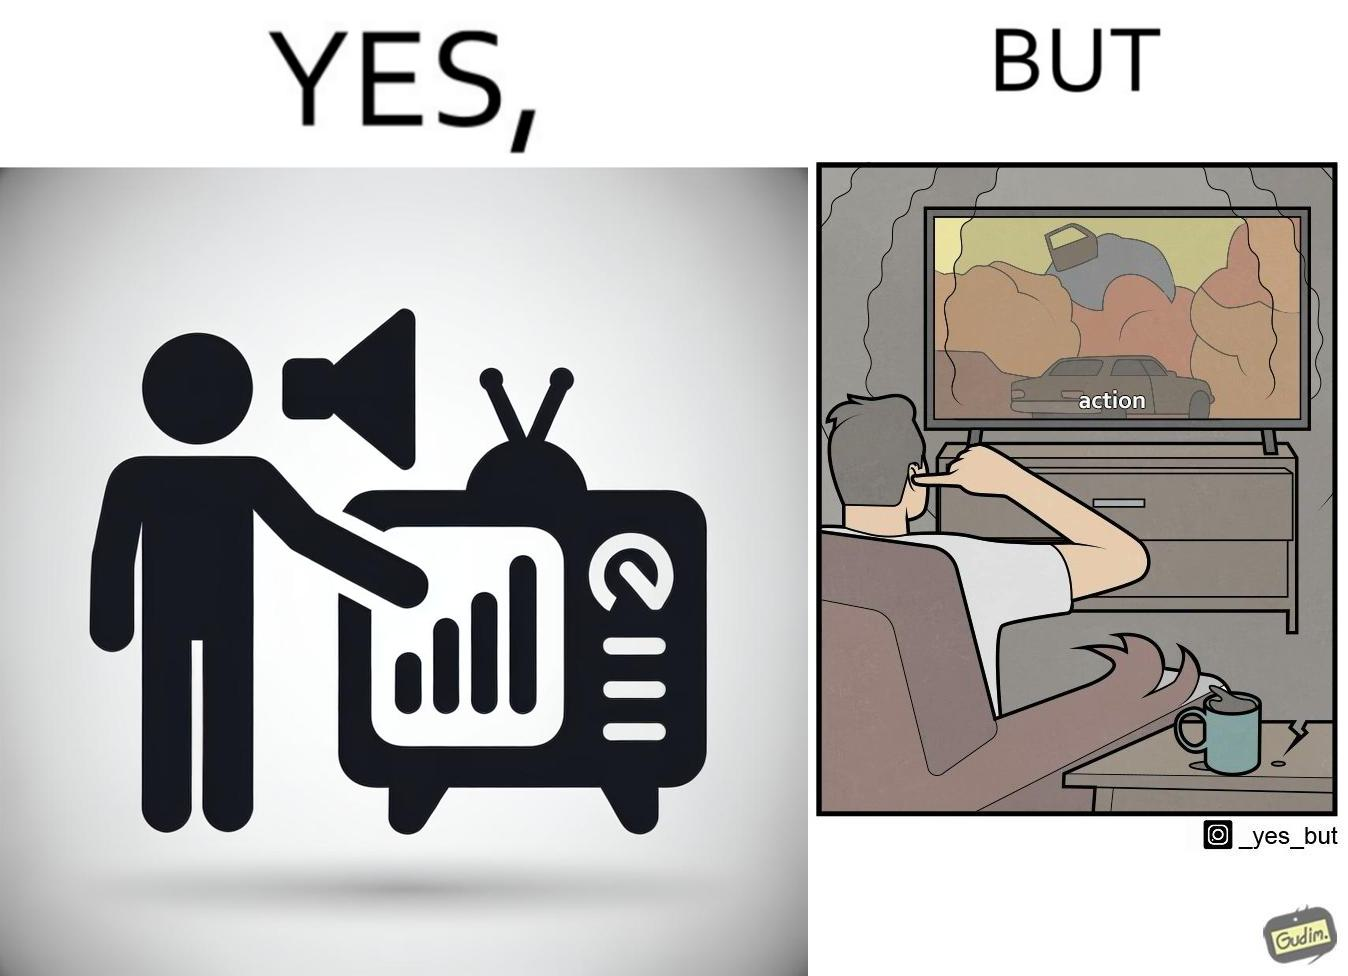What do you see in each half of this image? In the left part of the image: a person watching TV and increasing the volume of TV, maybe because he is not able to hear the dialogues properly In the right part of the image: a person covering his ears from the loud noise of TV, maybe because of the action scenes 